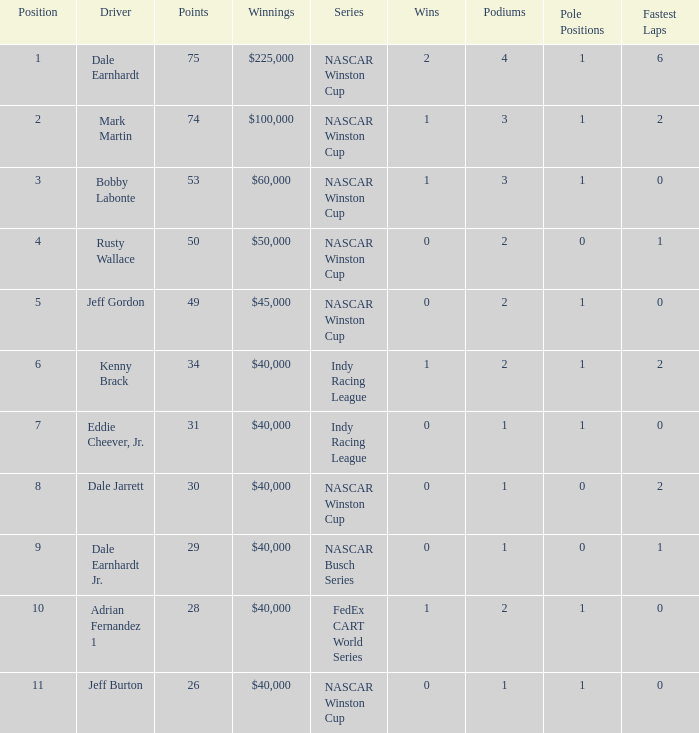Could you parse the entire table? {'header': ['Position', 'Driver', 'Points', 'Winnings', 'Series', 'Wins', 'Podiums', 'Pole Positions', 'Fastest Laps'], 'rows': [['1', 'Dale Earnhardt', '75', '$225,000', 'NASCAR Winston Cup', '2', '4', '1', '6'], ['2', 'Mark Martin', '74', '$100,000', 'NASCAR Winston Cup', '1', '3', '1', '2'], ['3', 'Bobby Labonte', '53', '$60,000', 'NASCAR Winston Cup', '1', '3', '1', '0'], ['4', 'Rusty Wallace', '50', '$50,000', 'NASCAR Winston Cup', '0', '2', '0', '1'], ['5', 'Jeff Gordon', '49', '$45,000', 'NASCAR Winston Cup', '0', '2', '1', '0'], ['6', 'Kenny Brack', '34', '$40,000', 'Indy Racing League', '1', '2', '1', '2'], ['7', 'Eddie Cheever, Jr.', '31', '$40,000', 'Indy Racing League', '0', '1', '1', '0'], ['8', 'Dale Jarrett', '30', '$40,000', 'NASCAR Winston Cup', '0', '1', '0', '2'], ['9', 'Dale Earnhardt Jr.', '29', '$40,000', 'NASCAR Busch Series', '0', '1', '0', '1'], ['10', 'Adrian Fernandez 1', '28', '$40,000', 'FedEx CART World Series', '1', '2', '1', '0'], ['11', 'Jeff Burton', '26', '$40,000', 'NASCAR Winston Cup', '0', '1', '1', '0']]} What position did the driver earn 31 points? 7.0. 